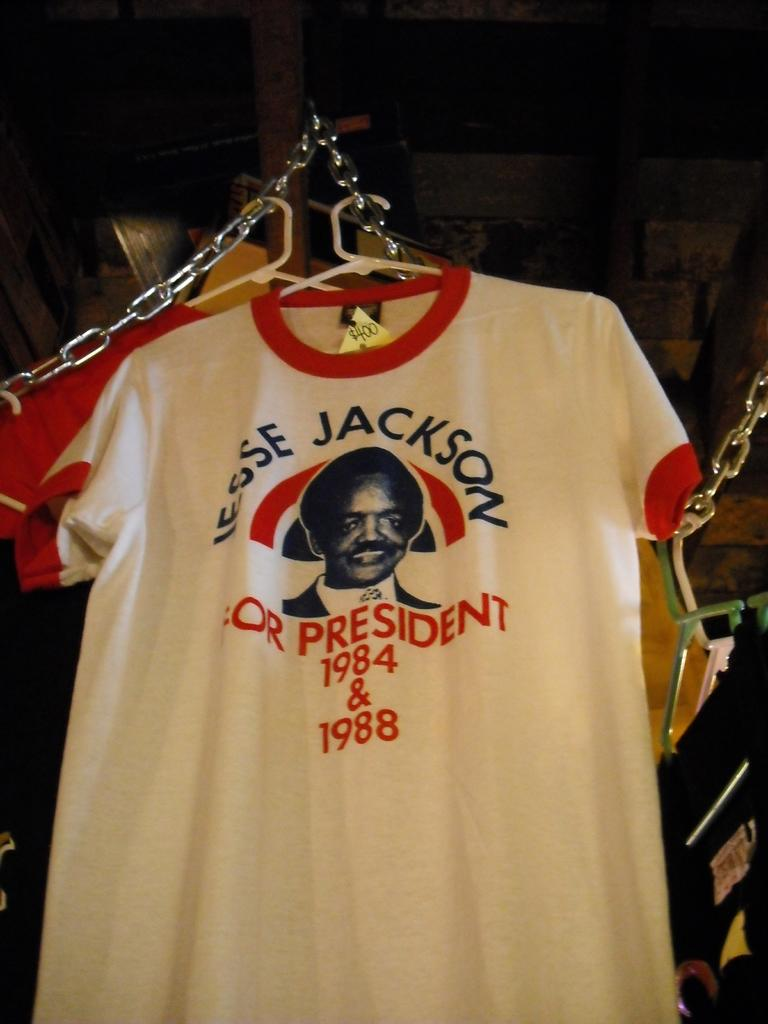<image>
Provide a brief description of the given image. The t-shirt suggests Jesse Jackson for President in 1984 & 1988. 